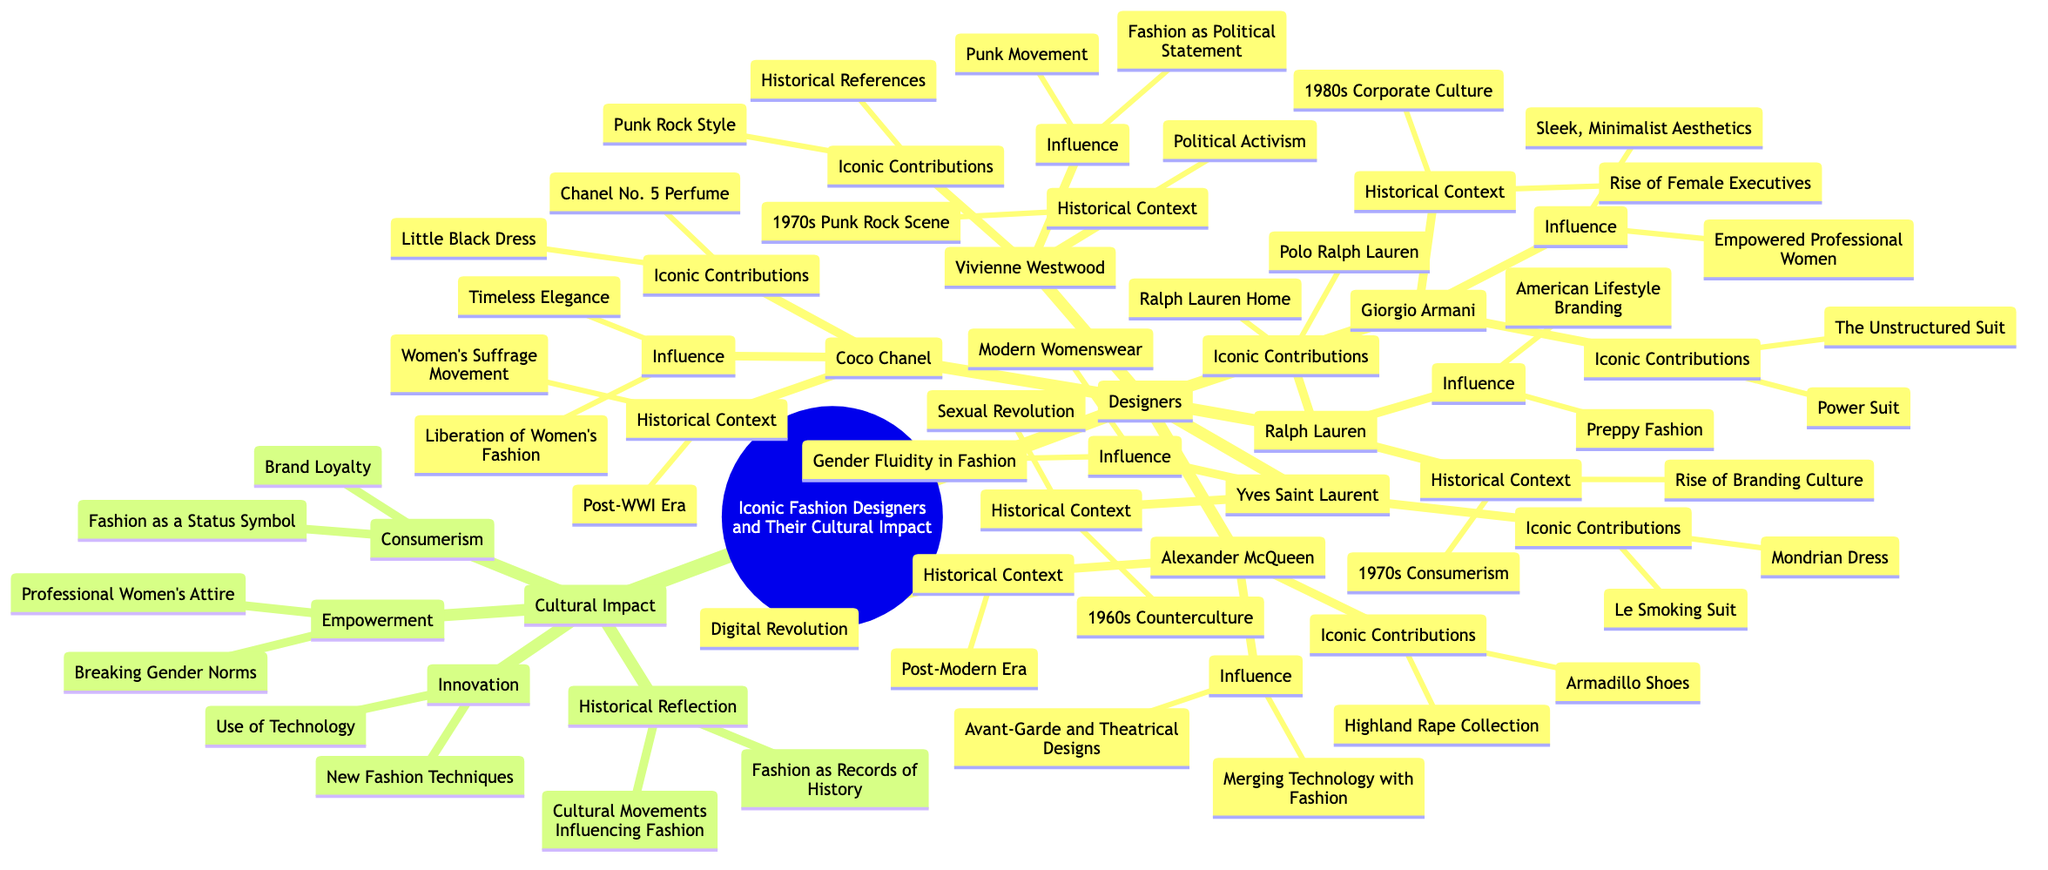What are the iconic contributions of Coco Chanel? The diagram outlines that the iconic contributions of Coco Chanel are the Little Black Dress and Chanel No. 5 Perfume. Each contribution is listed under the section for Coco Chanel, providing straightforward access to this information.
Answer: Little Black Dress, Chanel No. 5 Perfume How many designers are shown in the concept map? By counting the entries under the Designers section, we find six names: Coco Chanel, Yves Saint Laurent, Giorgio Armani, Vivienne Westwood, Alexander McQueen, and Ralph Lauren, confirming the total number of designers.
Answer: 6 What does Ralph Lauren influence? The diagram indicates that Ralph Lauren influences American Lifestyle Branding and Preppy Fashion, both of which are specified under his influence section.
Answer: American Lifestyle Branding, Preppy Fashion What is the historical context for Vivienne Westwood? The historical context for Vivienne Westwood listed in the diagram is the 1970s Punk Rock Scene and Political Activism. This information can be found under the appropriate section for her.
Answer: 1970s Punk Rock Scene, Political Activism Which designer contributed the Le Smoking Suit? Looking at the designers, Yves Saint Laurent is specified as the one who contributed the Le Smoking Suit, based on the contributions listed under his name.
Answer: Yves Saint Laurent How many influences are attributed to Giorgio Armani? There are two influences attributed to Giorgio Armani: Empowered Professional Women and Sleek, Minimalist Aesthetics, as seen in the corresponding section of the diagram.
Answer: 2 What are the cultural impacts associated with innovation? Under the Cultural Impact section, innovation is associated with New Fashion Techniques and Use of Technology, which can be found in that relevant subsection.
Answer: New Fashion Techniques, Use of Technology Which designer is associated with the concept of Gender Fluidity in Fashion? The diagram shows that Yves Saint Laurent is associated with the concept of Gender Fluidity in Fashion, clearly indicated in the influences attributed to him.
Answer: Yves Saint Laurent What was the cultural context of the Highland Rape Collection? The cultural context corresponding to the Highland Rape Collection is the Post-Modern Era and Digital Revolution, which can be referenced in the historical context section linked to Alexander McQueen.
Answer: Post-Modern Era, Digital Revolution 